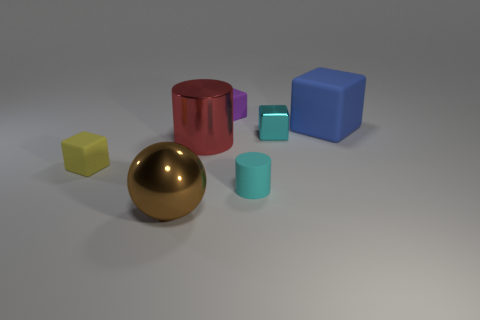Are there any cyan rubber balls that have the same size as the rubber cylinder? No, there are no cyan rubber balls that match the size of the rubber cylinder in the image. The only objects resembling a sphere and a cylinder are the gold ball and the red cylinder, respectively, which differ in both color and material. 